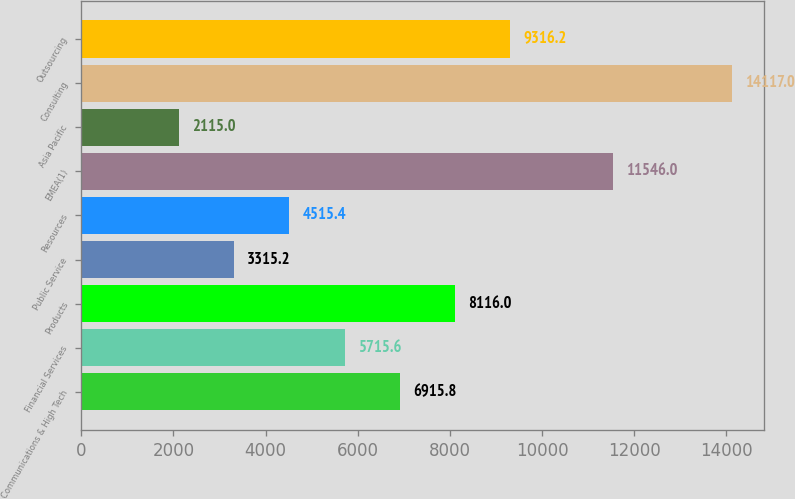<chart> <loc_0><loc_0><loc_500><loc_500><bar_chart><fcel>Communications & High Tech<fcel>Financial Services<fcel>Products<fcel>Public Service<fcel>Resources<fcel>EMEA(1)<fcel>Asia Pacific<fcel>Consulting<fcel>Outsourcing<nl><fcel>6915.8<fcel>5715.6<fcel>8116<fcel>3315.2<fcel>4515.4<fcel>11546<fcel>2115<fcel>14117<fcel>9316.2<nl></chart> 